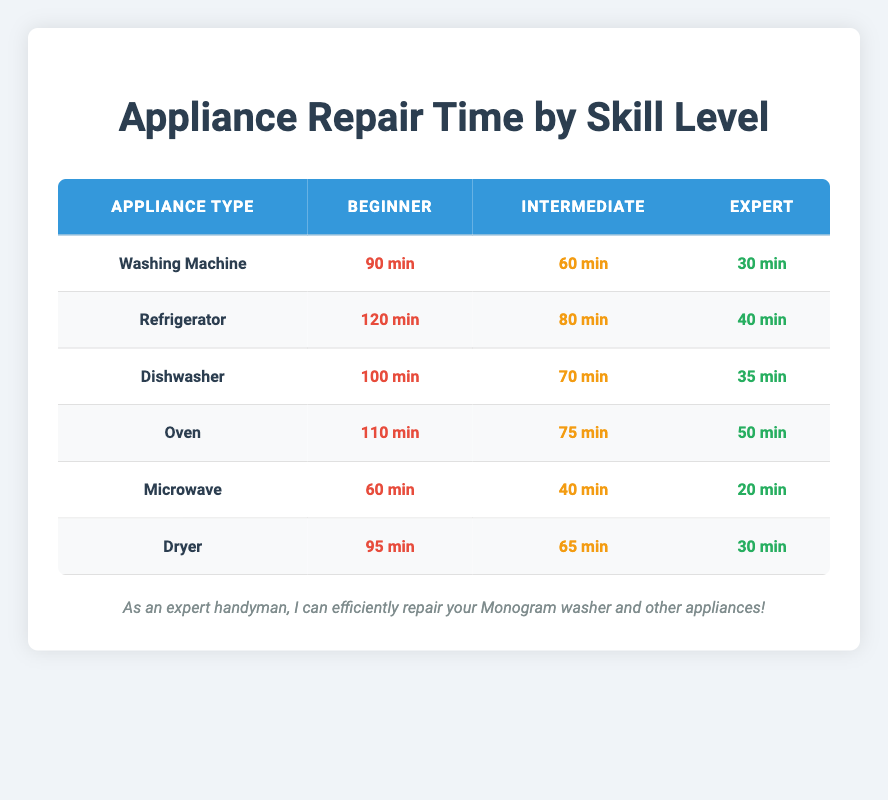What is the time taken by an Expert to fix a Washing Machine? According to the table, an Expert takes 30 minutes to fix a Washing Machine.
Answer: 30 min What appliance takes the longest to repair for a Beginner? By looking at the Beginner times, the Refrigerator takes 120 minutes, which is longer than any other appliance listed.
Answer: Refrigerator Is the time taken by an Expert to fix a Microwave less than that for a Dryer? The Expert takes 20 minutes for a Microwave and 30 minutes for a Dryer. Since 20 is less than 30, the statement is true.
Answer: Yes What is the difference in repair time between Beginner and Intermediate skill levels for the Dishwasher? The Beginner takes 100 minutes and the Intermediate takes 70 minutes. The difference is 100 - 70 = 30 minutes.
Answer: 30 min What is the average time taken for an Intermediate to repair all appliances? The Intermediate repair times are 60, 80, 70, 75, 40, and 65 minutes. Summing these gives 60 + 80 + 70 + 75 + 40 + 65 = 390 minutes, and dividing by 6 gives an average of 390 / 6 = 65 minutes.
Answer: 65 min Do Experts take more time to fix an Oven than an Intermediate? An Expert takes 50 minutes for an Oven, while an Intermediate takes 75 minutes for the same appliance. Since 50 is less than 75, the answer is false.
Answer: No What is the total time it would take for a Beginner to fix all appliances? Adding the Beginner times: 90 + 120 + 100 + 110 + 60 + 95 = 675 minutes.
Answer: 675 min Which appliance requires the least time for an Intermediate to repair? For Intermediate times, the least is 40 minutes for a Microwave.
Answer: Microwave What is the median time taken for an Expert across all appliances? The Expert times are 30, 40, 35, 50, 20, and 30 minutes. Arranging these gives 20, 30, 30, 35, 40, 50. The median is the average of the 3rd and 4th values: (35 + 30) / 2 = 32.5 minutes.
Answer: 32.5 min 